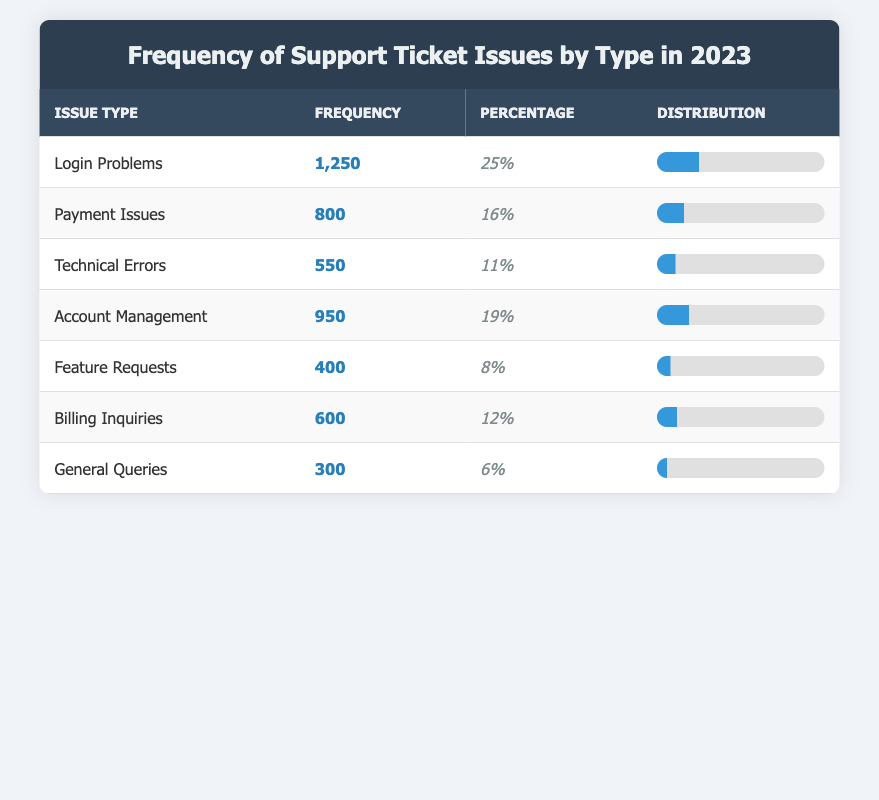What is the issue type with the highest frequency of support tickets? The issue type with the highest frequency is "Login Problems," which has a frequency of 1,250. This is directly indicated in the frequency column of the table.
Answer: Login Problems How many support tickets are related to "Payment Issues"? The frequency of support tickets related to "Payment Issues" is 800, as seen in the frequency column of that row in the table.
Answer: 800 What percentage of support tickets are related to "Feature Requests"? The percentage of support tickets related to "Feature Requests" is 8%, which is given directly in the percentage column for that issue type in the table.
Answer: 8% What is the total frequency of tickets for "Technical Errors" and "Billing Inquiries"? The total frequency for "Technical Errors" is 550 and for "Billing Inquiries" is 600. Adding these gives 550 + 600 = 1,150.
Answer: 1,150 Is the frequency of "General Queries" greater than the frequency of "Feature Requests"? The frequency for "General Queries" is 300, whereas for "Feature Requests" it is 400. Since 300 is less than 400, the statement is false.
Answer: No What is the average frequency of all support ticket issues listed? There are 7 issue types with frequencies: 1250, 800, 550, 950, 400, 600, and 300. The sum is 1250 + 800 + 550 + 950 + 400 + 600 + 300 = 4,800. To find the average, divide by 7: 4,800 / 7 = 685.71.
Answer: 685.71 Which issue type has the lowest frequency and what is that frequency? The issue type with the lowest frequency is "General Queries," which has a frequency of 300. This is directly observable in the frequency column of that row in the table.
Answer: General Queries, 300 What is the combined percentage of tickets for "Login Problems" and "Account Management"? The percentage for "Login Problems" is 25% and for "Account Management" is 19%. Adding these gives 25% + 19% = 44%.
Answer: 44% How many fewer tickets were reported for "Technical Errors" compared to "Payment Issues"? The frequency for "Payment Issues" is 800 and for "Technical Errors" is 550. The difference is 800 - 550 = 250.
Answer: 250 